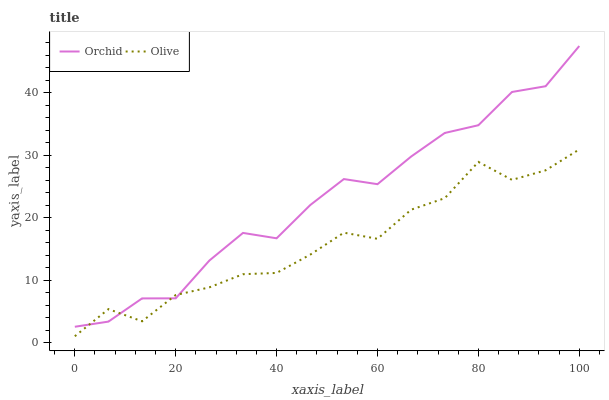Does Olive have the minimum area under the curve?
Answer yes or no. Yes. Does Orchid have the maximum area under the curve?
Answer yes or no. Yes. Does Orchid have the minimum area under the curve?
Answer yes or no. No. Is Olive the smoothest?
Answer yes or no. Yes. Is Orchid the roughest?
Answer yes or no. Yes. Is Orchid the smoothest?
Answer yes or no. No. Does Olive have the lowest value?
Answer yes or no. Yes. Does Orchid have the lowest value?
Answer yes or no. No. Does Orchid have the highest value?
Answer yes or no. Yes. Does Olive intersect Orchid?
Answer yes or no. Yes. Is Olive less than Orchid?
Answer yes or no. No. Is Olive greater than Orchid?
Answer yes or no. No. 